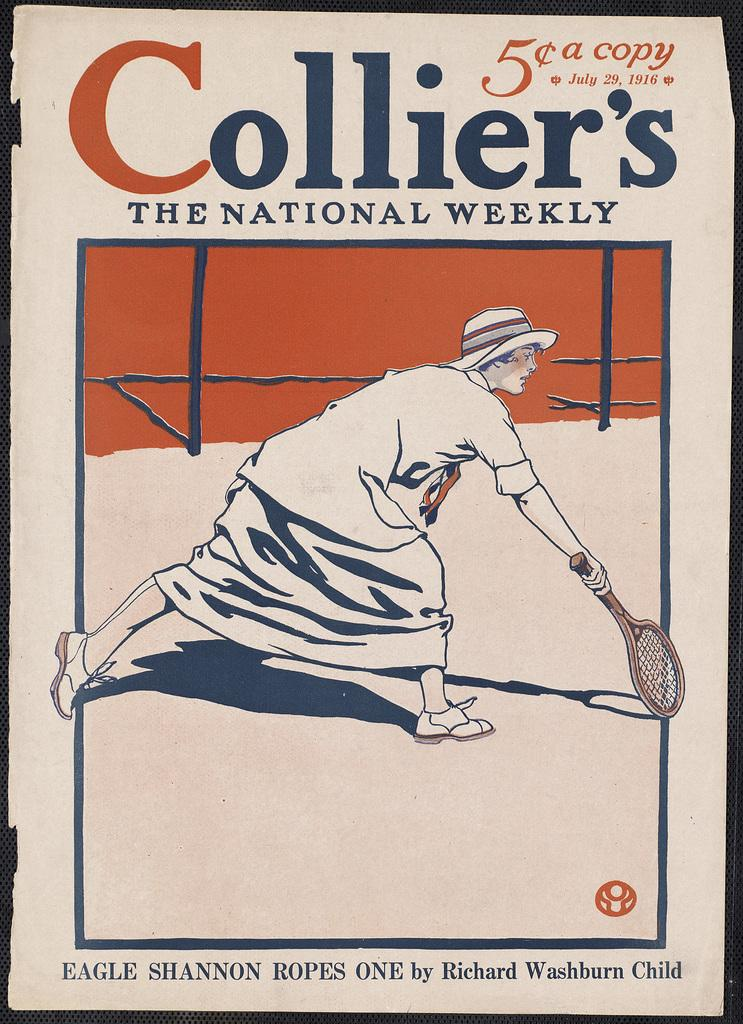What is depicted on the paper in the image? There is a person with a dress and hat on the paper. What is the person holding in the image? There is a person holding a bat in the image. What can be found on the paper besides the person? There is text on the paper. What type of sticks are being used to build the structure in the image? There is no structure or sticks present in the image; it features a paper with a person and text. 